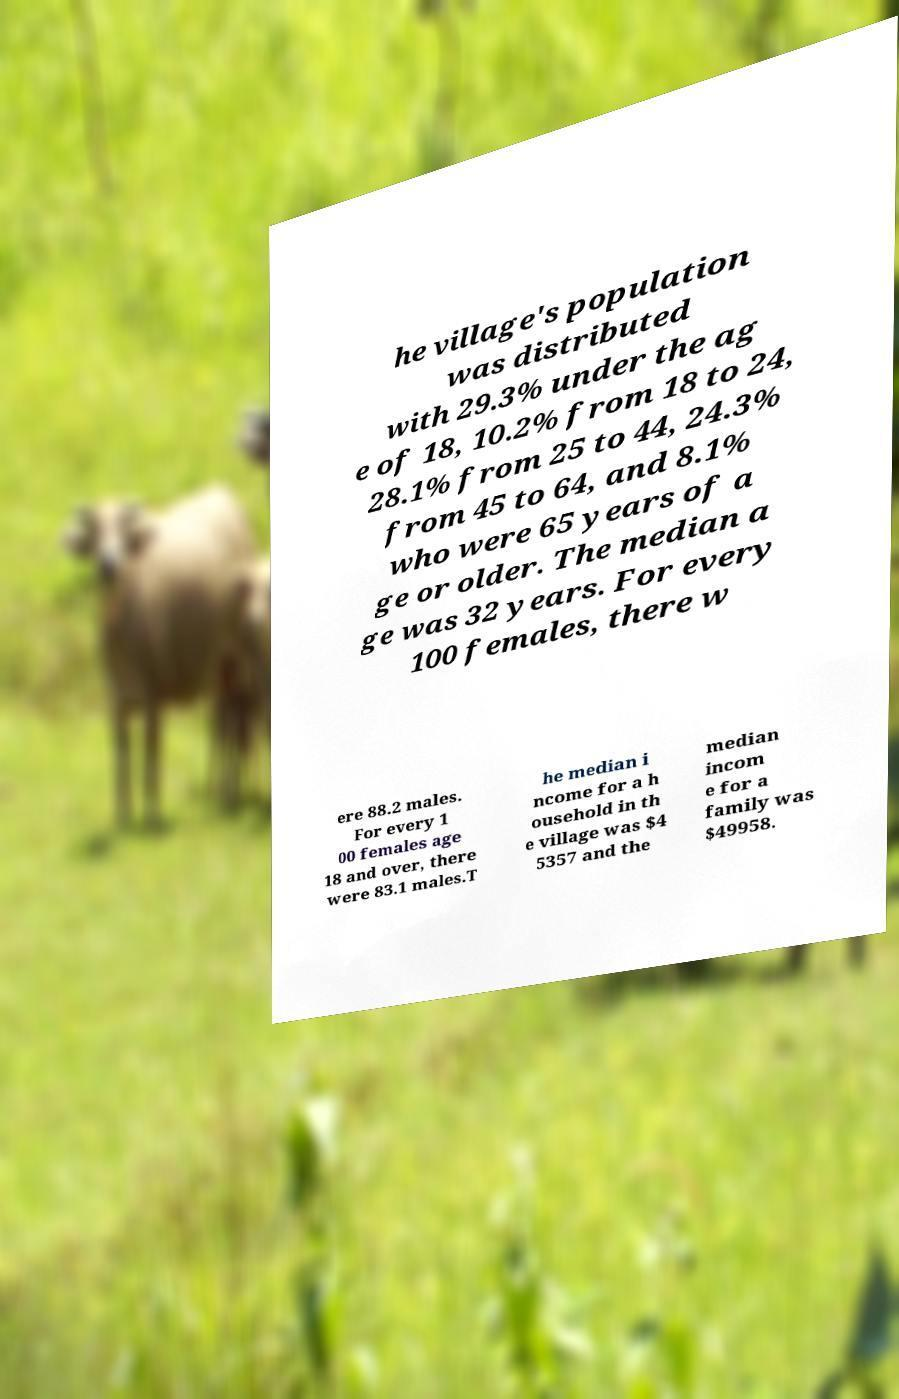For documentation purposes, I need the text within this image transcribed. Could you provide that? he village's population was distributed with 29.3% under the ag e of 18, 10.2% from 18 to 24, 28.1% from 25 to 44, 24.3% from 45 to 64, and 8.1% who were 65 years of a ge or older. The median a ge was 32 years. For every 100 females, there w ere 88.2 males. For every 1 00 females age 18 and over, there were 83.1 males.T he median i ncome for a h ousehold in th e village was $4 5357 and the median incom e for a family was $49958. 